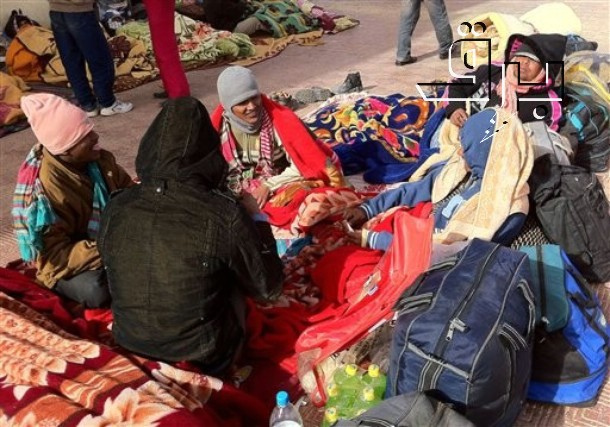What could we imagine this group doing once they get up and leave this spot? Once this group gets up and leaves, we can imagine them heading to their next destination, perhaps to find another place to rest or meet with others. They might be part of a larger community and are moving to share resources or provide support. With their spirits lifted by the warmth shared during this break, they would continue their journey, spreading kindness and solidarity wherever they go. Alternatively, if they are indeed performers, they might be moving to their next performance location, ready to entertain and inspire others with their art. 